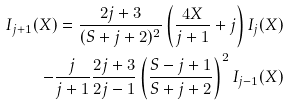Convert formula to latex. <formula><loc_0><loc_0><loc_500><loc_500>I _ { j + 1 } ( X ) = \frac { 2 j + 3 } { ( S + j + 2 ) ^ { 2 } } \left ( \frac { 4 X } { j + 1 } + j \right ) I _ { j } ( X ) \\ - \frac { j } { j + 1 } \frac { 2 j + 3 } { 2 j - 1 } \left ( \frac { S - j + 1 } { S + j + 2 } \right ) ^ { 2 } I _ { j - 1 } ( X )</formula> 